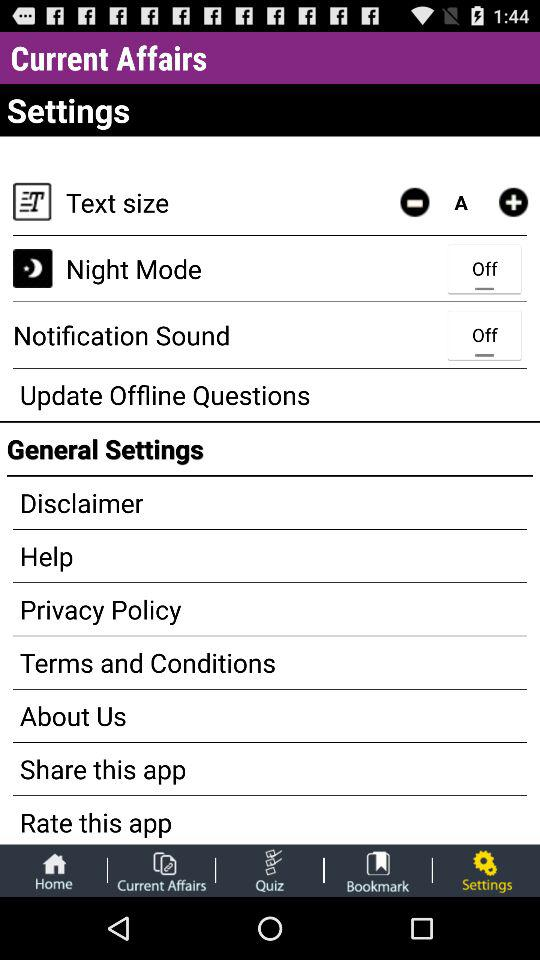What is the setting for text size? The setting for text size is "A". 